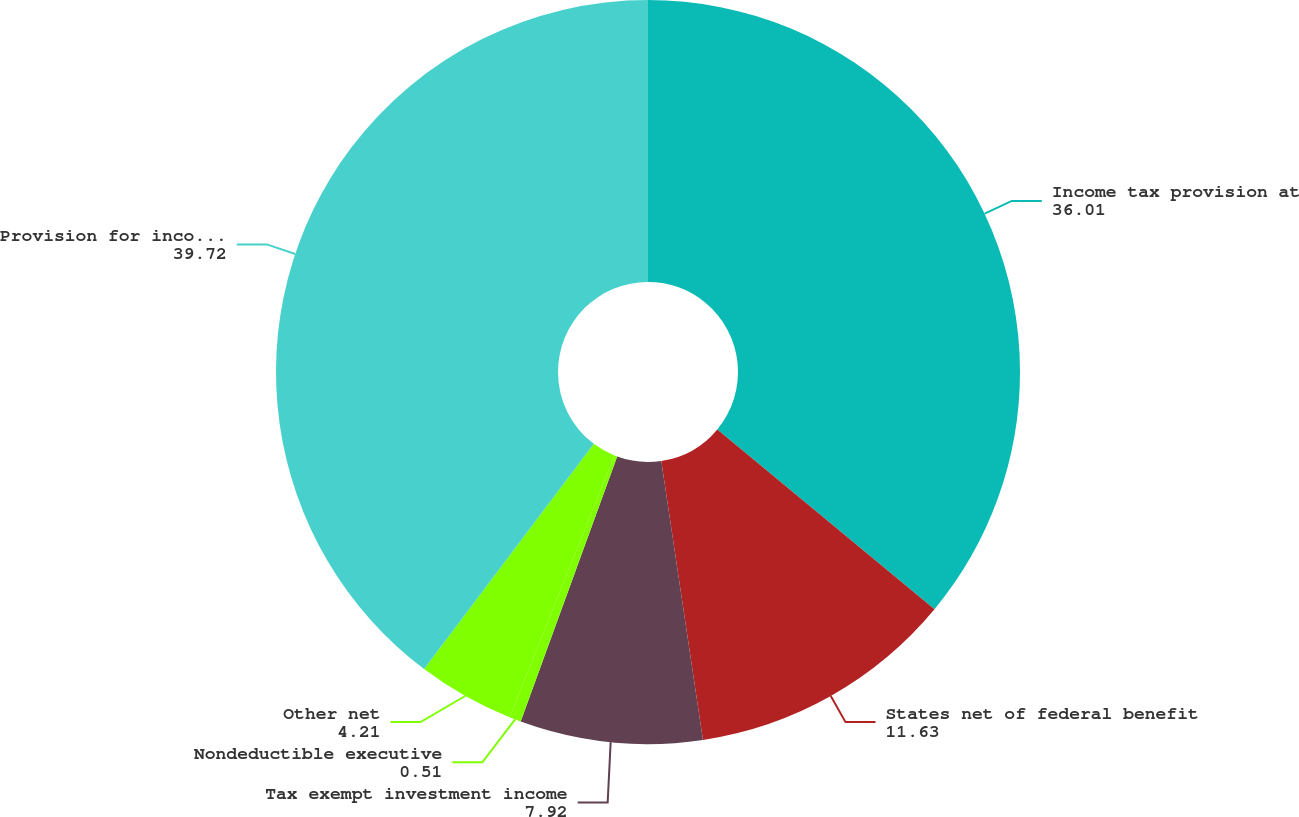Convert chart. <chart><loc_0><loc_0><loc_500><loc_500><pie_chart><fcel>Income tax provision at<fcel>States net of federal benefit<fcel>Tax exempt investment income<fcel>Nondeductible executive<fcel>Other net<fcel>Provision for income taxes<nl><fcel>36.01%<fcel>11.63%<fcel>7.92%<fcel>0.51%<fcel>4.21%<fcel>39.72%<nl></chart> 